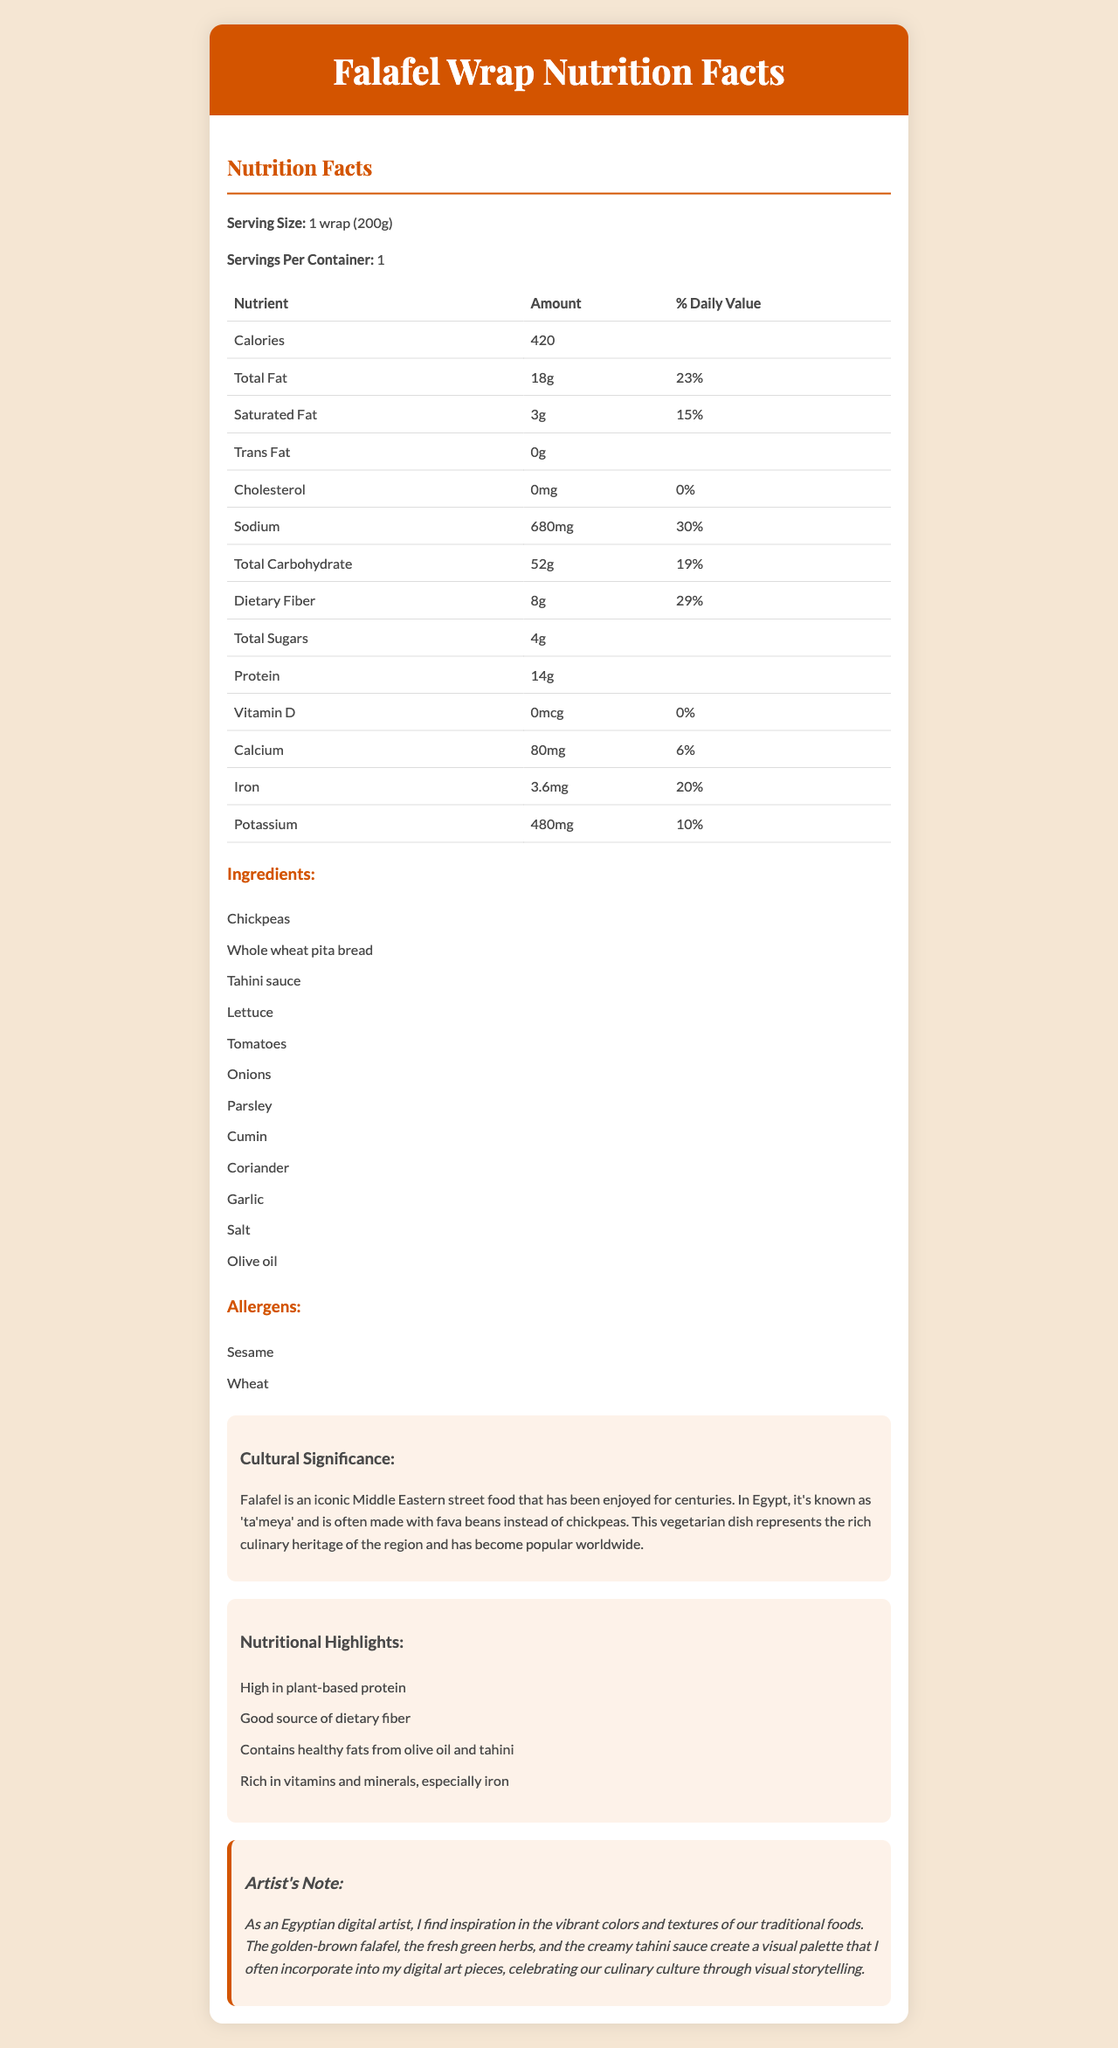What is the serving size of the Falafel Wrap? The serving size is listed at the top of the nutrition facts section as "1 wrap (200g)".
Answer: 1 wrap (200g) How many calories are in one Falafel Wrap? The document states that there are 420 calories per serving, and the serving size is 1 wrap, so there are 420 calories in one Falafel Wrap.
Answer: 420 What is the total amount of dietary fiber in one Falafel Wrap? The nutrition facts table lists dietary fiber as 8g per serving, which is one wrap.
Answer: 8g Which ingredient in the Falafel Wrap contains an allergen? A. Chickpeas B. Whole wheat pita bread C. Lettuce The allergens listed are sesame and wheat, and wheat is present in the whole wheat pita bread.
Answer: B What is the percentage of the daily value for iron provided by one Falafel Wrap? The document states that one Falafel Wrap provides 3.6 mg of iron, which is 20% of the daily value.
Answer: 20% What type of fat is completely absent in the Falafel Wrap? The document shows 0g for trans fat, indicating that the Falafel Wrap does not contain any trans fat.
Answer: Trans Fat Is the Falafel Wrap high in plant-based protein? The nutritional highlights section explicitly mentions that the Falafel Wrap is high in plant-based protein.
Answer: Yes What are the cultural origins of Falafel according to the document? The cultural significance section explains that falafel is an iconic Middle Eastern street food and is called 'ta'meya' in Egypt.
Answer: Middle Eastern, known as 'ta'meya' in Egypt What is a key visual element the artist finds inspiring in traditional foods like Falafel? A. Golden-brown falafel B. Smooth hummus C. Red chili flakes The artist's note mentions the golden-brown falafel as one of the inspiring visual elements.
Answer: A Summarize the main idea of the document. This document primarily offers comprehensive nutritional information about a Falafel Wrap, underscoring its cultural and health significance, along with an artistic perspective.
Answer: The document provides detailed nutrition facts for a Falafel Wrap, including serving size, calories, and various nutrients. It highlights the ingredients, potential allergens, and cultural significance of falafel as a traditional Middle Eastern dish. The nutritional highlights emphasize its health benefits, and the artist provides a note on how the dish inspires their digital art. How much sodium is in one Falafel Wrap? The sodium content is listed as 680mg per serving, which corresponds to one wrap.
Answer: 680mg Who has the greatest influence on the ingredient composition of the Falafel Wrap? The document does not provide details on who decides the ingredient composition of the Falafel Wrap.
Answer: Not enough information Which of the following nutrients is listed with a 0% daily value in the Falafel Wrap? A. Cholesterol B. Vitamin D C. Both A and B Both cholesterol and vitamin D are listed with 0% daily values in the nutrition facts table.
Answer: C Is the Falafel Wrap a good source of calcium? The calcium provided is 6% of the daily value, which is considered a low percentage and not a significant source.
Answer: No What is a common ingredient in the Falafel Wrap and traditional Egyptian 'ta'meya'? According to the cultural significance section, falafel is typically made with chickpeas, though in Egypt, 'ta'meya' is often made with fava beans.
Answer: Chickpeas or Fava beans (depending on the regional variation) 